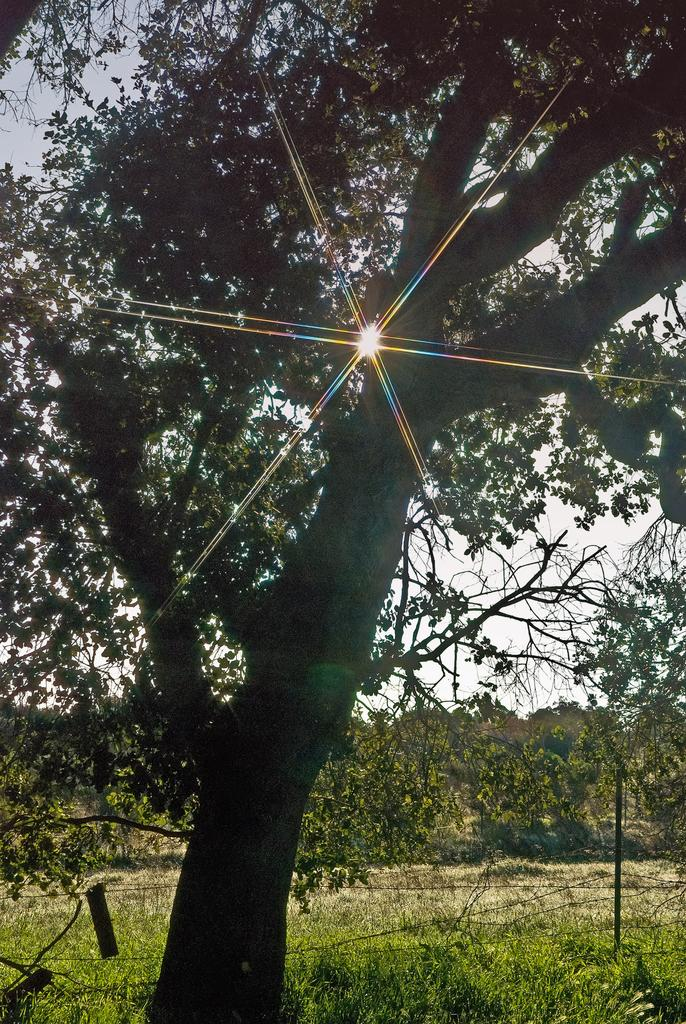What type of barrier can be seen in the image? There is a fence in the image. What type of vegetation is present is visible in the image? There is grass and trees in the image. What is the source of light in the image? Sunlight is visible in the image. What part of the natural environment is visible in the image? The sky is visible in the image. What type of location might the image represent? The image is likely taken in a farm. What time of day is the image likely taken? The image is likely taken during the day. What color is the vein of the daughter in the image? There is no daughter present in the image, and therefore no vein to describe. What season is depicted in the image? The provided facts do not specify a season, so we cannot determine if it is summer or any other season. 